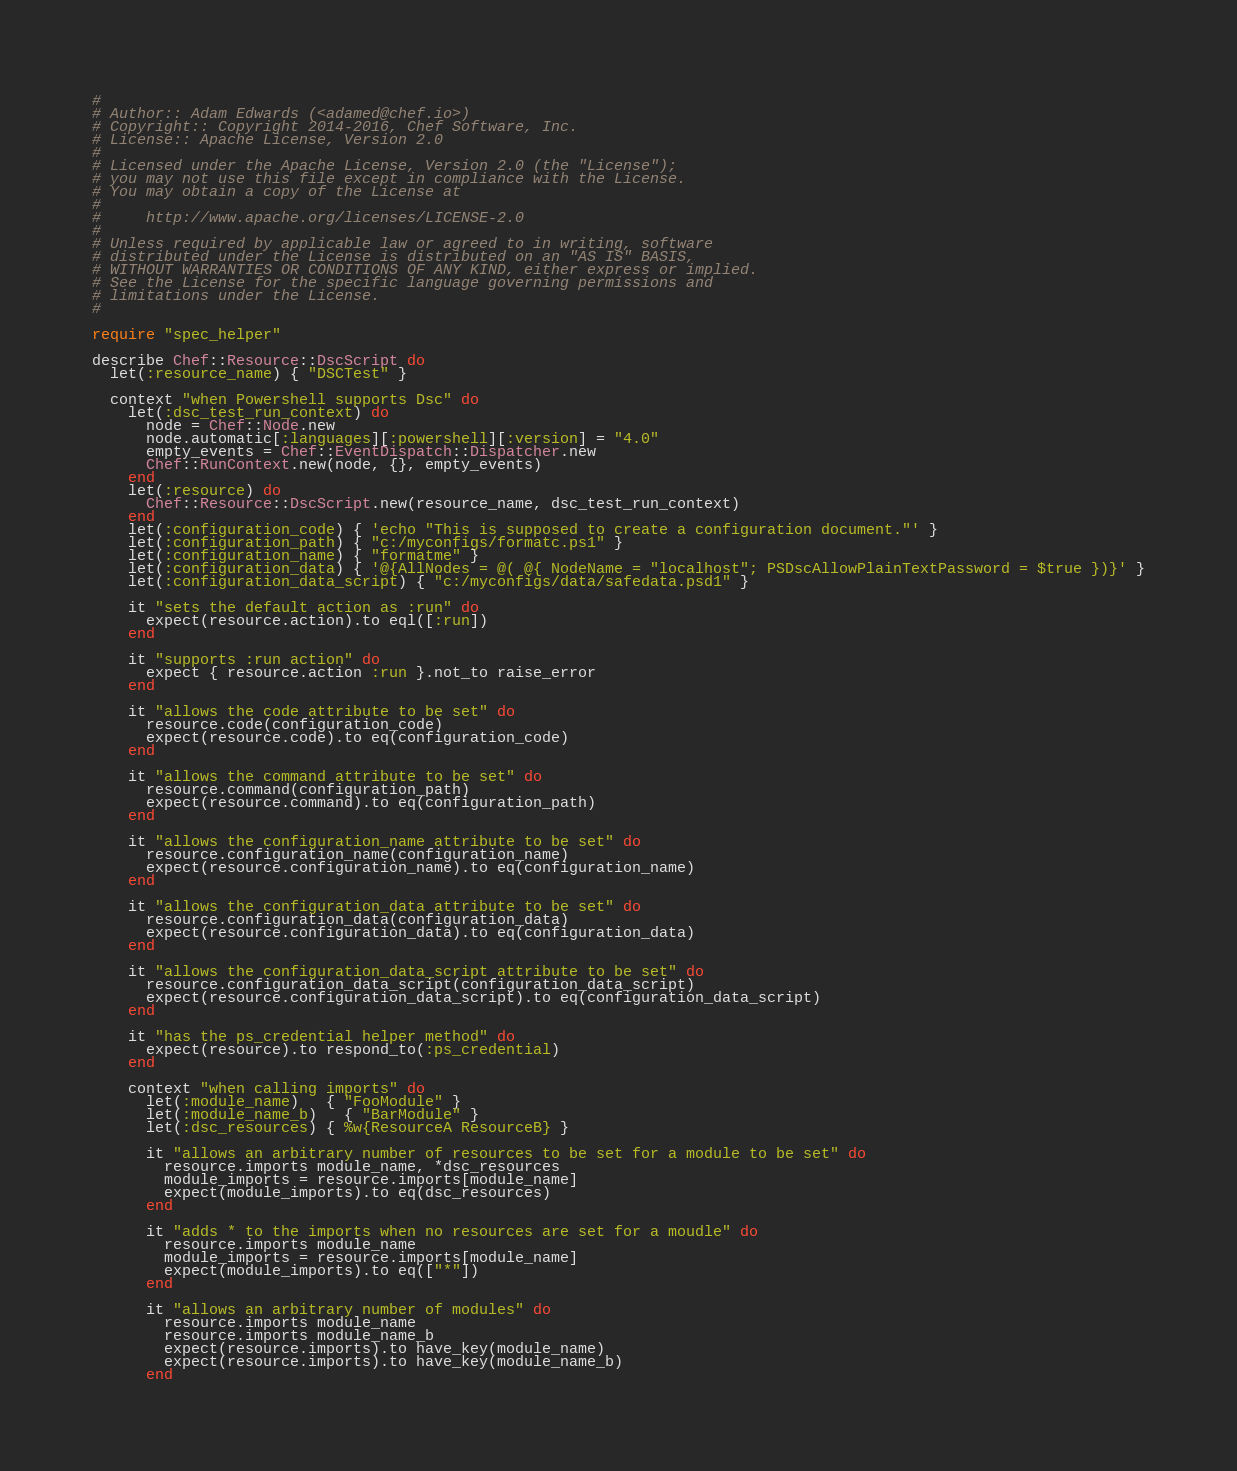Convert code to text. <code><loc_0><loc_0><loc_500><loc_500><_Ruby_>#
# Author:: Adam Edwards (<adamed@chef.io>)
# Copyright:: Copyright 2014-2016, Chef Software, Inc.
# License:: Apache License, Version 2.0
#
# Licensed under the Apache License, Version 2.0 (the "License");
# you may not use this file except in compliance with the License.
# You may obtain a copy of the License at
#
#     http://www.apache.org/licenses/LICENSE-2.0
#
# Unless required by applicable law or agreed to in writing, software
# distributed under the License is distributed on an "AS IS" BASIS,
# WITHOUT WARRANTIES OR CONDITIONS OF ANY KIND, either express or implied.
# See the License for the specific language governing permissions and
# limitations under the License.
#

require "spec_helper"

describe Chef::Resource::DscScript do
  let(:resource_name) { "DSCTest" }

  context "when Powershell supports Dsc" do
    let(:dsc_test_run_context) do
      node = Chef::Node.new
      node.automatic[:languages][:powershell][:version] = "4.0"
      empty_events = Chef::EventDispatch::Dispatcher.new
      Chef::RunContext.new(node, {}, empty_events)
    end
    let(:resource) do
      Chef::Resource::DscScript.new(resource_name, dsc_test_run_context)
    end
    let(:configuration_code) { 'echo "This is supposed to create a configuration document."' }
    let(:configuration_path) { "c:/myconfigs/formatc.ps1" }
    let(:configuration_name) { "formatme" }
    let(:configuration_data) { '@{AllNodes = @( @{ NodeName = "localhost"; PSDscAllowPlainTextPassword = $true })}' }
    let(:configuration_data_script) { "c:/myconfigs/data/safedata.psd1" }

    it "sets the default action as :run" do
      expect(resource.action).to eql([:run])
    end

    it "supports :run action" do
      expect { resource.action :run }.not_to raise_error
    end

    it "allows the code attribute to be set" do
      resource.code(configuration_code)
      expect(resource.code).to eq(configuration_code)
    end

    it "allows the command attribute to be set" do
      resource.command(configuration_path)
      expect(resource.command).to eq(configuration_path)
    end

    it "allows the configuration_name attribute to be set" do
      resource.configuration_name(configuration_name)
      expect(resource.configuration_name).to eq(configuration_name)
    end

    it "allows the configuration_data attribute to be set" do
      resource.configuration_data(configuration_data)
      expect(resource.configuration_data).to eq(configuration_data)
    end

    it "allows the configuration_data_script attribute to be set" do
      resource.configuration_data_script(configuration_data_script)
      expect(resource.configuration_data_script).to eq(configuration_data_script)
    end

    it "has the ps_credential helper method" do
      expect(resource).to respond_to(:ps_credential)
    end

    context "when calling imports" do
      let(:module_name)   { "FooModule" }
      let(:module_name_b)   { "BarModule" }
      let(:dsc_resources) { %w{ResourceA ResourceB} }

      it "allows an arbitrary number of resources to be set for a module to be set" do
        resource.imports module_name, *dsc_resources
        module_imports = resource.imports[module_name]
        expect(module_imports).to eq(dsc_resources)
      end

      it "adds * to the imports when no resources are set for a moudle" do
        resource.imports module_name
        module_imports = resource.imports[module_name]
        expect(module_imports).to eq(["*"])
      end

      it "allows an arbitrary number of modules" do
        resource.imports module_name
        resource.imports module_name_b
        expect(resource.imports).to have_key(module_name)
        expect(resource.imports).to have_key(module_name_b)
      end
</code> 